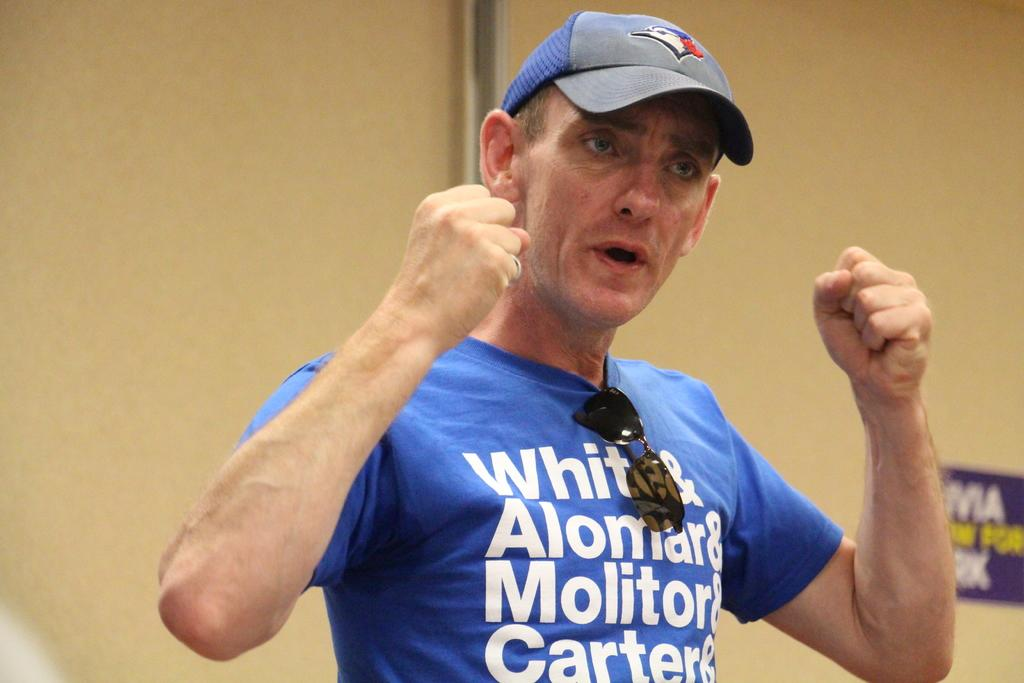<image>
Offer a succinct explanation of the picture presented. Man giving a speech wearing a shirt that says "White" on it. 